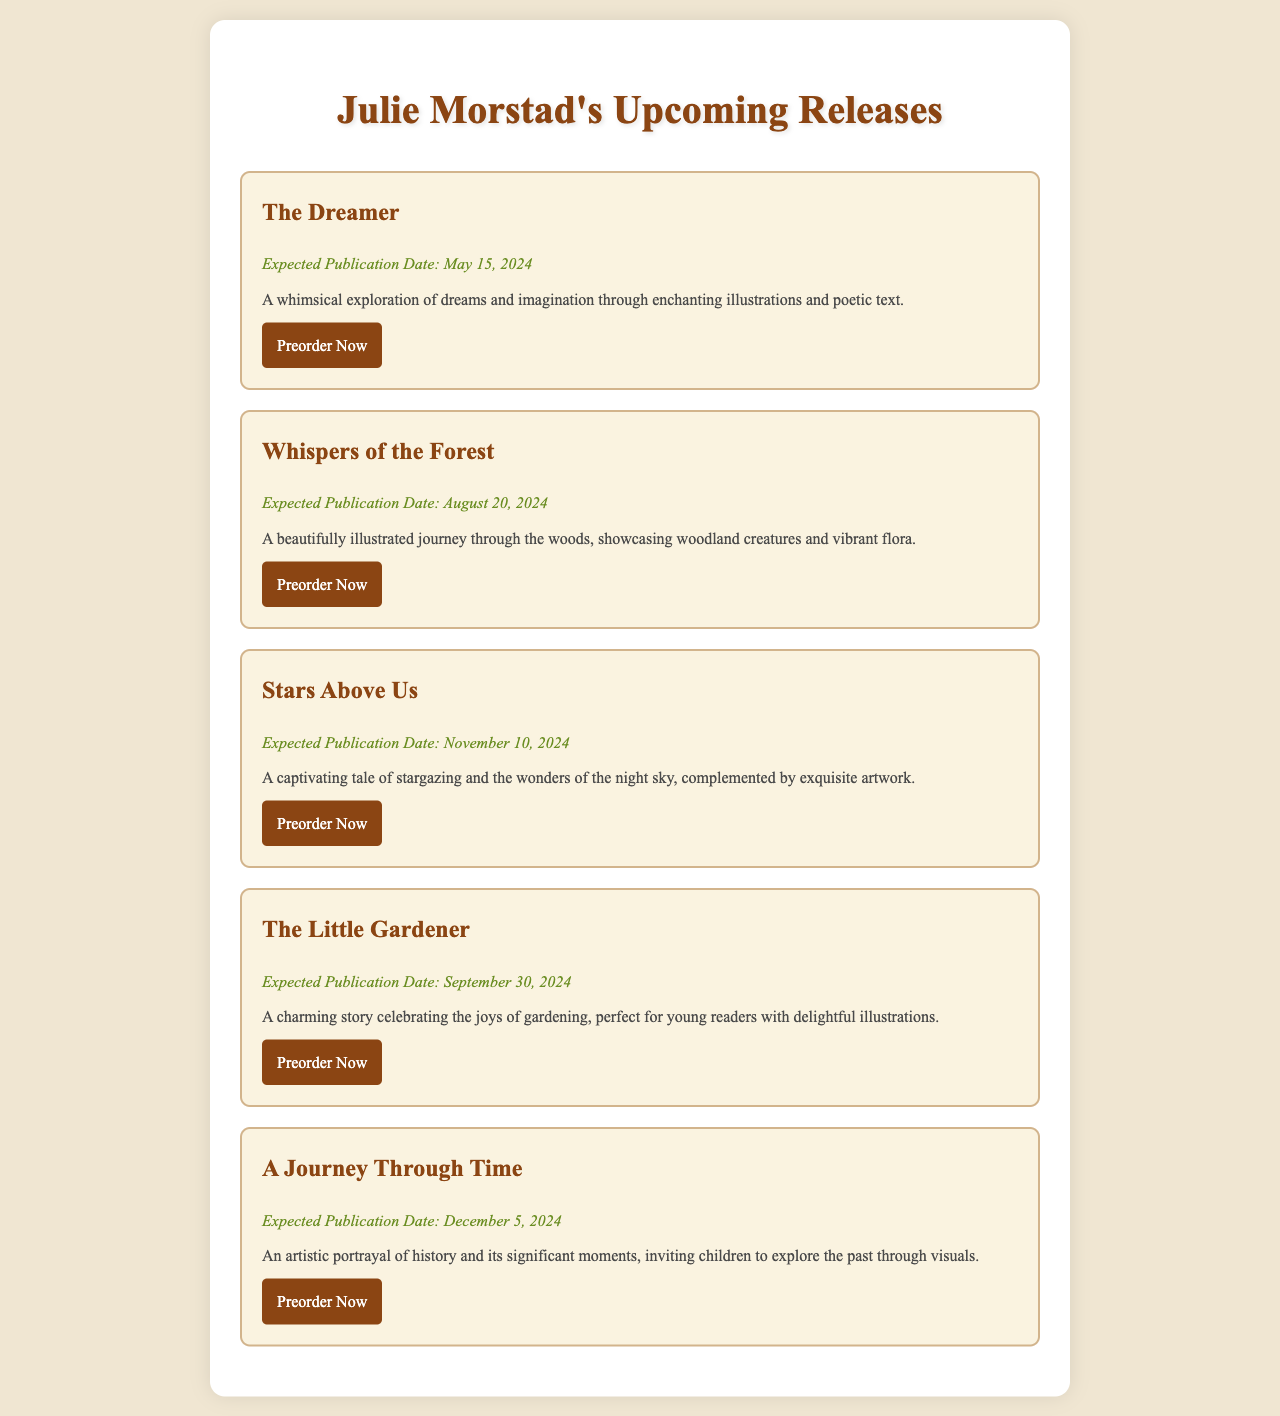what is the title of the first upcoming book? The first upcoming book listed in the document is clearly stated as "The Dreamer."
Answer: The Dreamer when is "Whispers of the Forest" expected to be published? The expected publication date for "Whispers of the Forest" is specified in the document as August 20, 2024.
Answer: August 20, 2024 how many books are listed as upcoming releases? The document provides a list of five upcoming releases by counting all listed books.
Answer: 5 what is the expected publication date of "Stars Above Us"? The document outlines the expected publication date of "Stars Above Us" as November 10, 2024.
Answer: November 10, 2024 what is the main theme of "The Little Gardener"? The description of "The Little Gardener" mentions it celebrates the joys of gardening, indicating its main theme.
Answer: Gardening what should you do to preorder "A Journey Through Time"? The document provides a clear action instruction stating you should follow the preorder link to secure "A Journey Through Time."
Answer: Preorder Now which book is associated with a journey through the woods? The document specifies "Whispers of the Forest" as the book related to a journey through the woods.
Answer: Whispers of the Forest what color is the background of the document? The background color of the document is described as a light beige or cream tone, specifically #f0e6d2.
Answer: Light beige who is the illustrator of the upcoming books? The introductory context of the document indicates that all upcoming books are illustrated by Julie Morstad.
Answer: Julie Morstad 